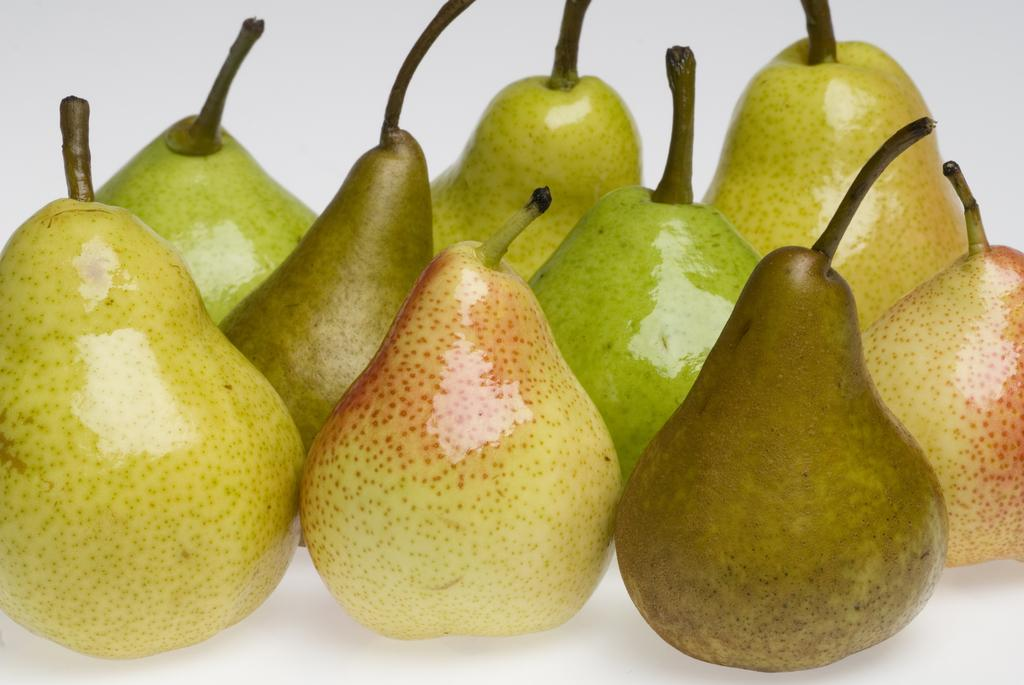What type of food is visible in the image? There are fruits in the image. How do the fruits resemble peas? The fruits in the image are small and round, similar to peas. What color is the background of the image? The background of the image is white. Can you hear a bird singing in the background of the image? There is no sound or bird present in the image, as it is a still image. 